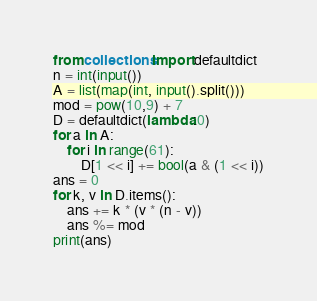Convert code to text. <code><loc_0><loc_0><loc_500><loc_500><_Python_>from collections import defaultdict
n = int(input())
A = list(map(int, input().split()))
mod = pow(10,9) + 7
D = defaultdict(lambda:0)
for a in A:
    for i in range(61):
        D[1 << i] += bool(a & (1 << i))
ans = 0
for k, v in D.items():
    ans += k * (v * (n - v))
    ans %= mod
print(ans)</code> 